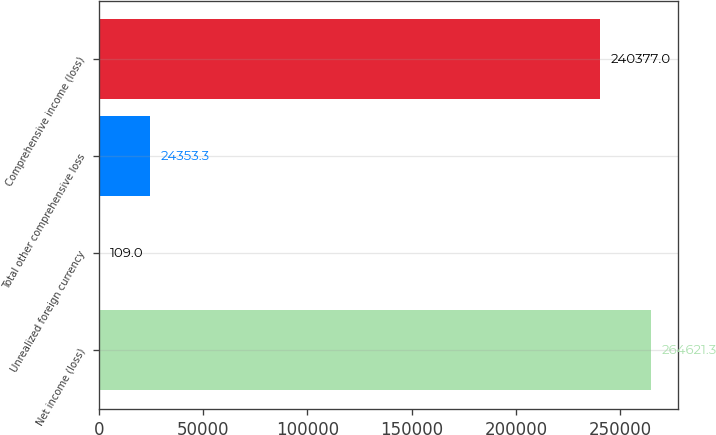<chart> <loc_0><loc_0><loc_500><loc_500><bar_chart><fcel>Net income (loss)<fcel>Unrealized foreign currency<fcel>Total other comprehensive loss<fcel>Comprehensive income (loss)<nl><fcel>264621<fcel>109<fcel>24353.3<fcel>240377<nl></chart> 